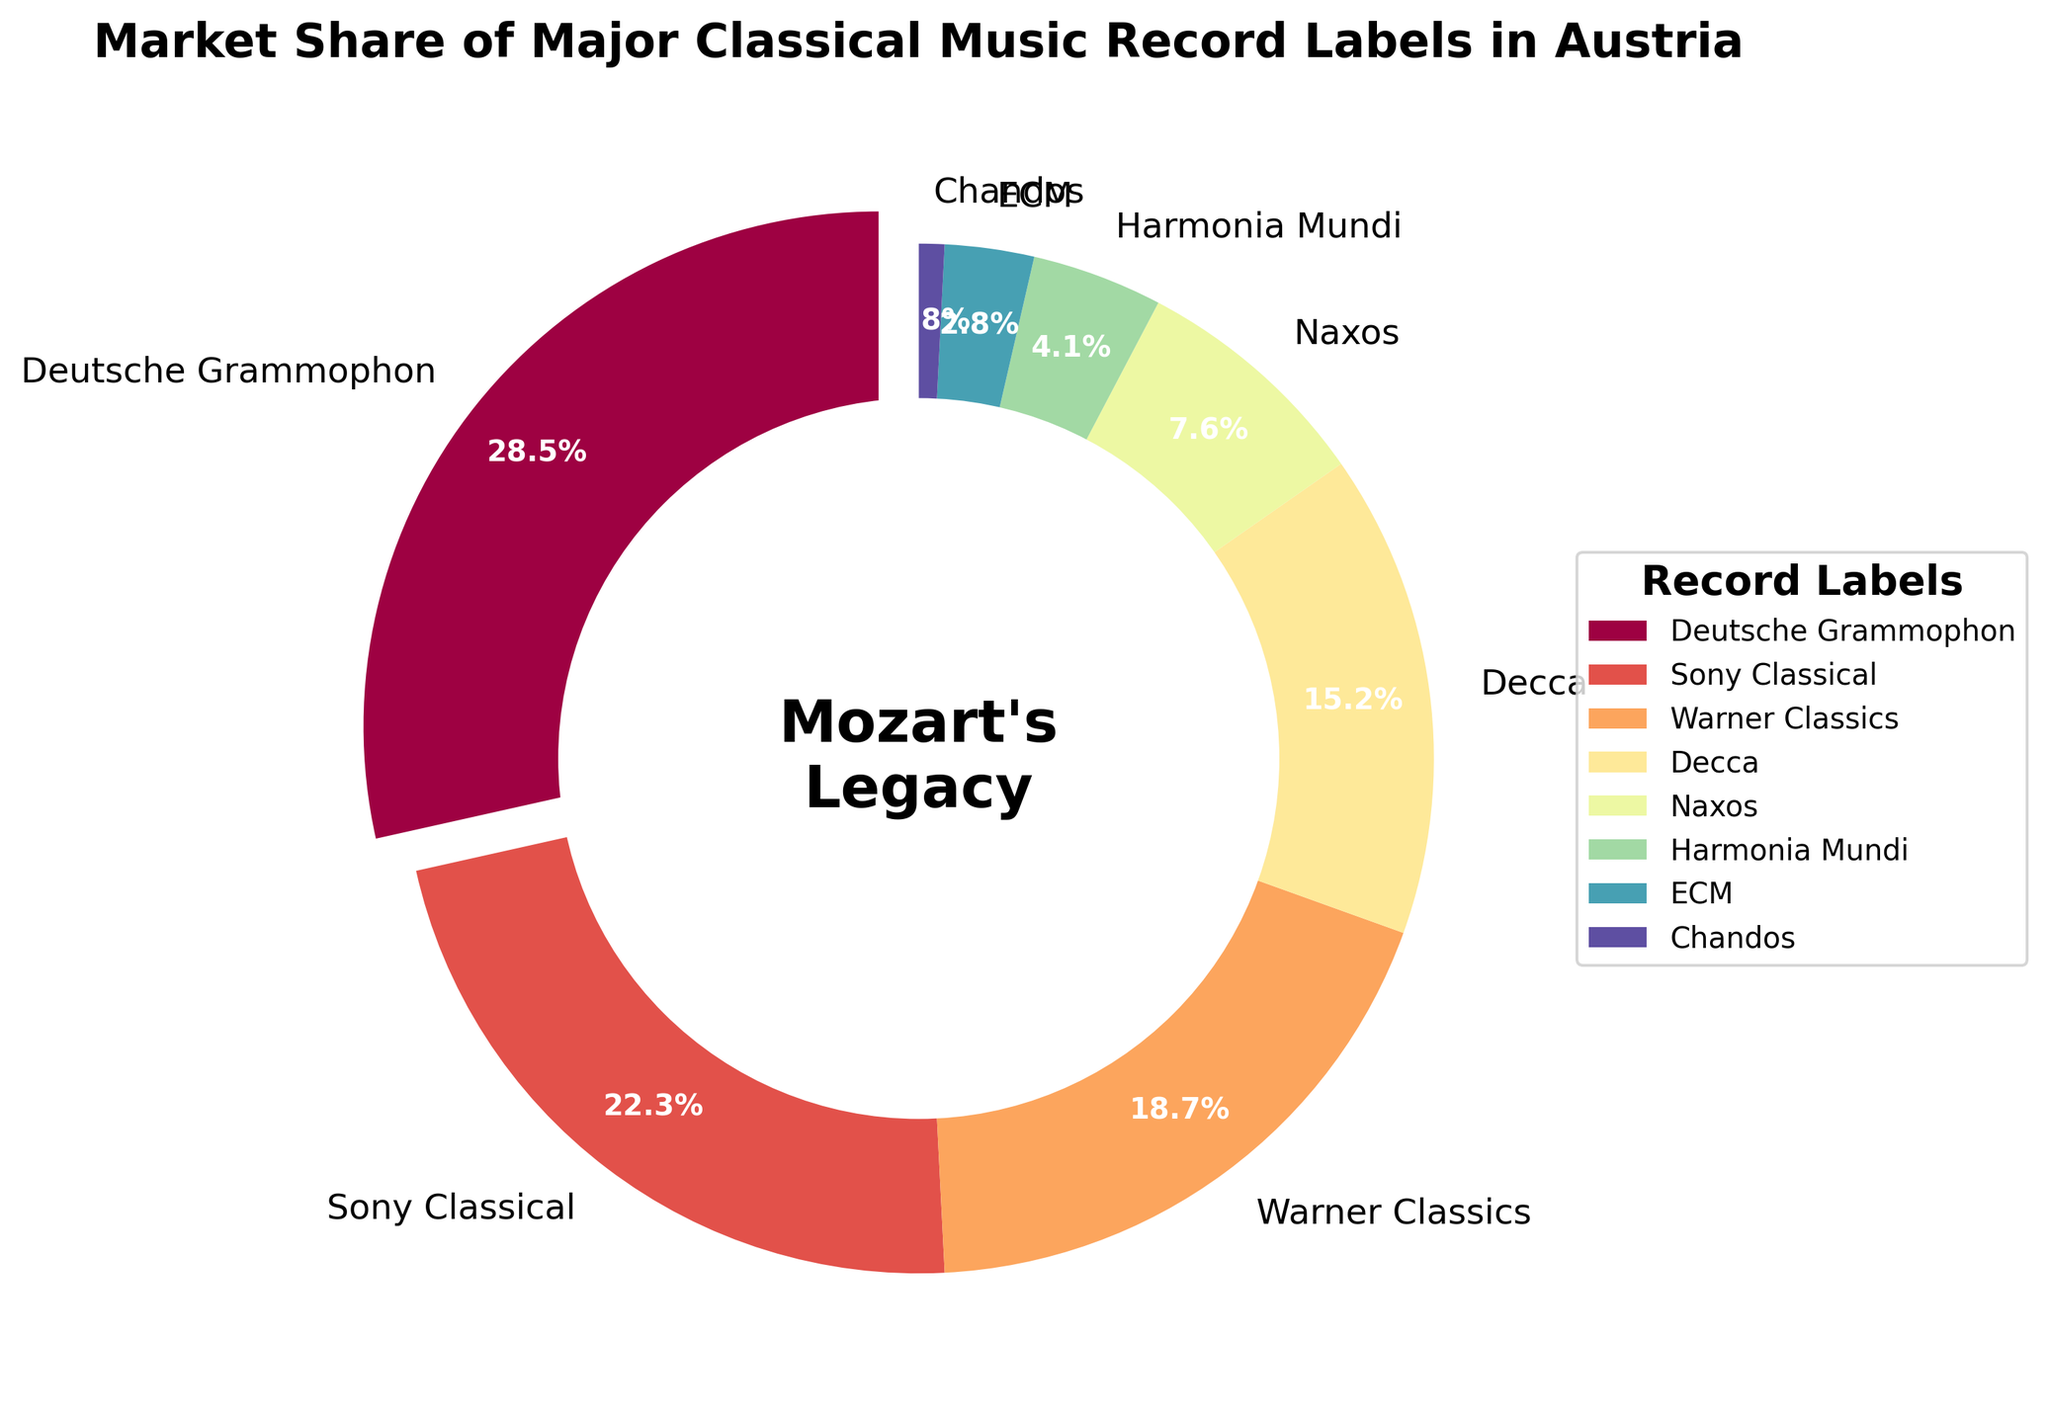What's the market share of Deutsche Grammophon? Deutsche Grammophon is one of the slices in the figure, and its corresponding market share is labeled as 28.5%
Answer: 28.5% Which record label has the smallest market share? By looking at the pie chart, the smallest slice corresponds to Chandos, which has a market share label of 0.8%.
Answer: Chandos How much more market share does Deutsche Grammophon have compared to Sony Classical? Deutsche Grammophon’s market share is 28.5% and Sony Classical’s is 22.3%. The difference is 28.5% - 22.3% = 6.2%
Answer: 6.2% What is the combined market share of Decca and Naxos? Decca has a market share of 15.2% and Naxos has 7.6%. Their combined share is 15.2% + 7.6% = 22.8%
Answer: 22.8% Which three record labels have the highest market share? By looking at the sizes and labels of the slices, the highest market shares are from Deutsche Grammophon, Sony Classical, and Warner Classics.
Answer: Deutsche Grammophon, Sony Classical, Warner Classics How many labels have a market share less than 10%? By observing the labeled slices: Naxos (7.6%), Harmonia Mundi (4.1%), ECM (2.8%), and Chandos (0.8%)—counting them gives 4.
Answer: 4 What color represents Warner Classics in the figure? The figure uses colors from the Spectral colormap. The specific color for Warner Classics would be visually identifiable as part of this colormap, typically a color closer to the middle of the range.
Answer: (Assumed but varies based on rendering) If you combine the market shares of Sony Classical, Warner Classics, and Decca, does it exceed the share of Deutsche Grammophon? Sony Classical, Warner Classics, and Decca have market shares of 22.3%, 18.7%, and 15.2%, respectively. Summing these: 22.3% + 18.7% + 15.2% = 56.2%, which is greater than 28.5% (Deutsche Grammophon).
Answer: Yes 